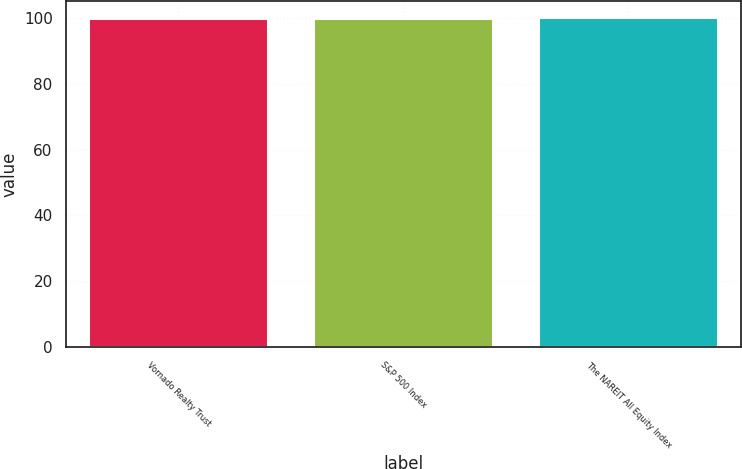<chart> <loc_0><loc_0><loc_500><loc_500><bar_chart><fcel>Vornado Realty Trust<fcel>S&P 500 Index<fcel>The NAREIT All Equity Index<nl><fcel>100<fcel>100.1<fcel>100.2<nl></chart> 